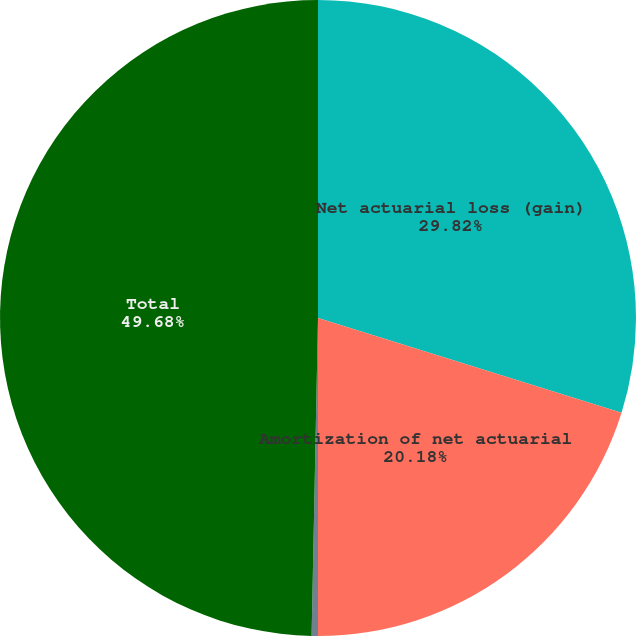<chart> <loc_0><loc_0><loc_500><loc_500><pie_chart><fcel>Net actuarial loss (gain)<fcel>Amortization of net actuarial<fcel>Prior service cost arising<fcel>Total<nl><fcel>29.82%<fcel>20.18%<fcel>0.32%<fcel>49.68%<nl></chart> 